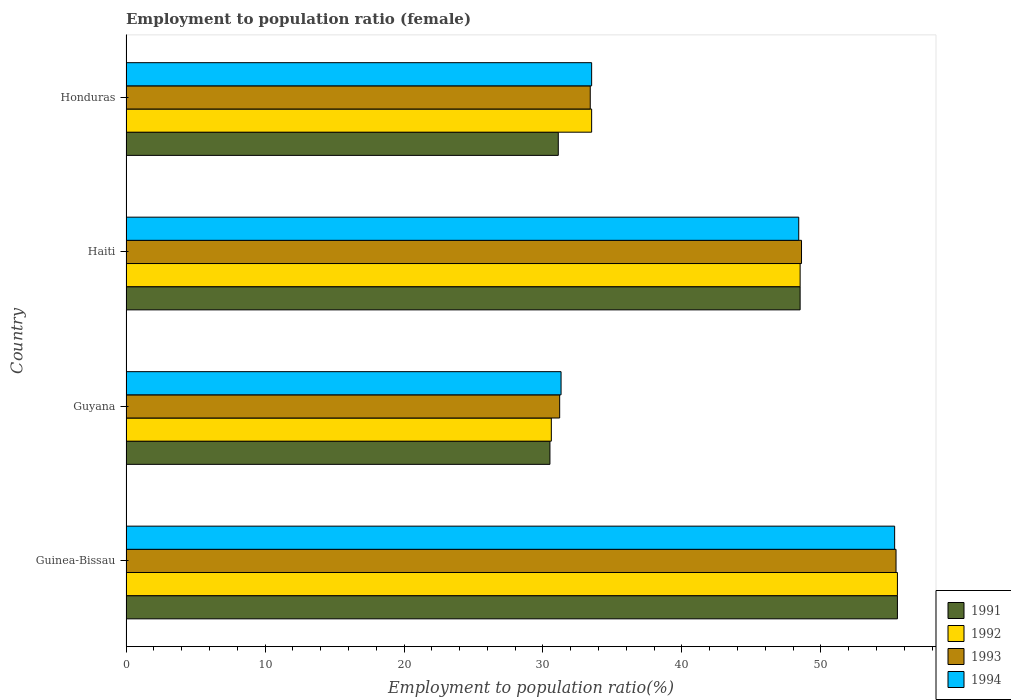How many different coloured bars are there?
Offer a very short reply. 4. How many groups of bars are there?
Your answer should be very brief. 4. Are the number of bars on each tick of the Y-axis equal?
Keep it short and to the point. Yes. What is the label of the 4th group of bars from the top?
Provide a succinct answer. Guinea-Bissau. In how many cases, is the number of bars for a given country not equal to the number of legend labels?
Your response must be concise. 0. What is the employment to population ratio in 1994 in Guyana?
Your answer should be very brief. 31.3. Across all countries, what is the maximum employment to population ratio in 1994?
Offer a very short reply. 55.3. Across all countries, what is the minimum employment to population ratio in 1993?
Keep it short and to the point. 31.2. In which country was the employment to population ratio in 1994 maximum?
Keep it short and to the point. Guinea-Bissau. In which country was the employment to population ratio in 1991 minimum?
Give a very brief answer. Guyana. What is the total employment to population ratio in 1993 in the graph?
Provide a short and direct response. 168.6. What is the difference between the employment to population ratio in 1991 in Guinea-Bissau and that in Honduras?
Your answer should be compact. 24.4. What is the difference between the employment to population ratio in 1993 in Guinea-Bissau and the employment to population ratio in 1992 in Haiti?
Your answer should be compact. 6.9. What is the average employment to population ratio in 1992 per country?
Give a very brief answer. 42.03. What is the difference between the employment to population ratio in 1991 and employment to population ratio in 1993 in Haiti?
Offer a very short reply. -0.1. In how many countries, is the employment to population ratio in 1992 greater than 6 %?
Keep it short and to the point. 4. What is the ratio of the employment to population ratio in 1992 in Guyana to that in Honduras?
Ensure brevity in your answer.  0.91. Is the difference between the employment to population ratio in 1991 in Guinea-Bissau and Guyana greater than the difference between the employment to population ratio in 1993 in Guinea-Bissau and Guyana?
Your response must be concise. Yes. What is the difference between the highest and the second highest employment to population ratio in 1994?
Provide a short and direct response. 6.9. What is the difference between the highest and the lowest employment to population ratio in 1991?
Provide a succinct answer. 25. In how many countries, is the employment to population ratio in 1991 greater than the average employment to population ratio in 1991 taken over all countries?
Ensure brevity in your answer.  2. Is the sum of the employment to population ratio in 1993 in Guinea-Bissau and Honduras greater than the maximum employment to population ratio in 1991 across all countries?
Keep it short and to the point. Yes. Is it the case that in every country, the sum of the employment to population ratio in 1994 and employment to population ratio in 1993 is greater than the sum of employment to population ratio in 1992 and employment to population ratio in 1991?
Your response must be concise. No. What does the 1st bar from the top in Haiti represents?
Ensure brevity in your answer.  1994. Is it the case that in every country, the sum of the employment to population ratio in 1993 and employment to population ratio in 1994 is greater than the employment to population ratio in 1992?
Your answer should be very brief. Yes. How many bars are there?
Offer a very short reply. 16. Are all the bars in the graph horizontal?
Offer a terse response. Yes. How many countries are there in the graph?
Ensure brevity in your answer.  4. What is the difference between two consecutive major ticks on the X-axis?
Provide a short and direct response. 10. Are the values on the major ticks of X-axis written in scientific E-notation?
Your answer should be very brief. No. What is the title of the graph?
Keep it short and to the point. Employment to population ratio (female). Does "2013" appear as one of the legend labels in the graph?
Your response must be concise. No. What is the label or title of the X-axis?
Offer a very short reply. Employment to population ratio(%). What is the label or title of the Y-axis?
Offer a very short reply. Country. What is the Employment to population ratio(%) in 1991 in Guinea-Bissau?
Ensure brevity in your answer.  55.5. What is the Employment to population ratio(%) in 1992 in Guinea-Bissau?
Offer a terse response. 55.5. What is the Employment to population ratio(%) of 1993 in Guinea-Bissau?
Your answer should be compact. 55.4. What is the Employment to population ratio(%) in 1994 in Guinea-Bissau?
Provide a succinct answer. 55.3. What is the Employment to population ratio(%) of 1991 in Guyana?
Keep it short and to the point. 30.5. What is the Employment to population ratio(%) in 1992 in Guyana?
Provide a succinct answer. 30.6. What is the Employment to population ratio(%) in 1993 in Guyana?
Keep it short and to the point. 31.2. What is the Employment to population ratio(%) of 1994 in Guyana?
Provide a short and direct response. 31.3. What is the Employment to population ratio(%) in 1991 in Haiti?
Offer a terse response. 48.5. What is the Employment to population ratio(%) in 1992 in Haiti?
Ensure brevity in your answer.  48.5. What is the Employment to population ratio(%) in 1993 in Haiti?
Offer a terse response. 48.6. What is the Employment to population ratio(%) of 1994 in Haiti?
Your answer should be compact. 48.4. What is the Employment to population ratio(%) of 1991 in Honduras?
Ensure brevity in your answer.  31.1. What is the Employment to population ratio(%) in 1992 in Honduras?
Provide a short and direct response. 33.5. What is the Employment to population ratio(%) of 1993 in Honduras?
Your answer should be very brief. 33.4. What is the Employment to population ratio(%) of 1994 in Honduras?
Keep it short and to the point. 33.5. Across all countries, what is the maximum Employment to population ratio(%) of 1991?
Keep it short and to the point. 55.5. Across all countries, what is the maximum Employment to population ratio(%) of 1992?
Keep it short and to the point. 55.5. Across all countries, what is the maximum Employment to population ratio(%) of 1993?
Your answer should be very brief. 55.4. Across all countries, what is the maximum Employment to population ratio(%) in 1994?
Make the answer very short. 55.3. Across all countries, what is the minimum Employment to population ratio(%) of 1991?
Offer a terse response. 30.5. Across all countries, what is the minimum Employment to population ratio(%) of 1992?
Your response must be concise. 30.6. Across all countries, what is the minimum Employment to population ratio(%) of 1993?
Your answer should be compact. 31.2. Across all countries, what is the minimum Employment to population ratio(%) of 1994?
Your answer should be compact. 31.3. What is the total Employment to population ratio(%) of 1991 in the graph?
Ensure brevity in your answer.  165.6. What is the total Employment to population ratio(%) in 1992 in the graph?
Make the answer very short. 168.1. What is the total Employment to population ratio(%) in 1993 in the graph?
Make the answer very short. 168.6. What is the total Employment to population ratio(%) of 1994 in the graph?
Your answer should be compact. 168.5. What is the difference between the Employment to population ratio(%) of 1991 in Guinea-Bissau and that in Guyana?
Offer a terse response. 25. What is the difference between the Employment to population ratio(%) of 1992 in Guinea-Bissau and that in Guyana?
Offer a very short reply. 24.9. What is the difference between the Employment to population ratio(%) of 1993 in Guinea-Bissau and that in Guyana?
Ensure brevity in your answer.  24.2. What is the difference between the Employment to population ratio(%) of 1994 in Guinea-Bissau and that in Guyana?
Make the answer very short. 24. What is the difference between the Employment to population ratio(%) in 1992 in Guinea-Bissau and that in Haiti?
Offer a very short reply. 7. What is the difference between the Employment to population ratio(%) of 1993 in Guinea-Bissau and that in Haiti?
Give a very brief answer. 6.8. What is the difference between the Employment to population ratio(%) of 1991 in Guinea-Bissau and that in Honduras?
Your answer should be very brief. 24.4. What is the difference between the Employment to population ratio(%) of 1994 in Guinea-Bissau and that in Honduras?
Give a very brief answer. 21.8. What is the difference between the Employment to population ratio(%) in 1992 in Guyana and that in Haiti?
Your answer should be very brief. -17.9. What is the difference between the Employment to population ratio(%) in 1993 in Guyana and that in Haiti?
Give a very brief answer. -17.4. What is the difference between the Employment to population ratio(%) of 1994 in Guyana and that in Haiti?
Ensure brevity in your answer.  -17.1. What is the difference between the Employment to population ratio(%) of 1991 in Guyana and that in Honduras?
Provide a succinct answer. -0.6. What is the difference between the Employment to population ratio(%) of 1992 in Guyana and that in Honduras?
Give a very brief answer. -2.9. What is the difference between the Employment to population ratio(%) in 1993 in Guyana and that in Honduras?
Your answer should be very brief. -2.2. What is the difference between the Employment to population ratio(%) in 1994 in Guyana and that in Honduras?
Make the answer very short. -2.2. What is the difference between the Employment to population ratio(%) of 1991 in Haiti and that in Honduras?
Provide a succinct answer. 17.4. What is the difference between the Employment to population ratio(%) in 1992 in Haiti and that in Honduras?
Provide a succinct answer. 15. What is the difference between the Employment to population ratio(%) in 1993 in Haiti and that in Honduras?
Make the answer very short. 15.2. What is the difference between the Employment to population ratio(%) of 1994 in Haiti and that in Honduras?
Offer a very short reply. 14.9. What is the difference between the Employment to population ratio(%) in 1991 in Guinea-Bissau and the Employment to population ratio(%) in 1992 in Guyana?
Make the answer very short. 24.9. What is the difference between the Employment to population ratio(%) of 1991 in Guinea-Bissau and the Employment to population ratio(%) of 1993 in Guyana?
Provide a short and direct response. 24.3. What is the difference between the Employment to population ratio(%) of 1991 in Guinea-Bissau and the Employment to population ratio(%) of 1994 in Guyana?
Your response must be concise. 24.2. What is the difference between the Employment to population ratio(%) of 1992 in Guinea-Bissau and the Employment to population ratio(%) of 1993 in Guyana?
Your answer should be very brief. 24.3. What is the difference between the Employment to population ratio(%) in 1992 in Guinea-Bissau and the Employment to population ratio(%) in 1994 in Guyana?
Offer a terse response. 24.2. What is the difference between the Employment to population ratio(%) in 1993 in Guinea-Bissau and the Employment to population ratio(%) in 1994 in Guyana?
Provide a succinct answer. 24.1. What is the difference between the Employment to population ratio(%) of 1992 in Guinea-Bissau and the Employment to population ratio(%) of 1993 in Haiti?
Provide a succinct answer. 6.9. What is the difference between the Employment to population ratio(%) of 1991 in Guinea-Bissau and the Employment to population ratio(%) of 1993 in Honduras?
Offer a terse response. 22.1. What is the difference between the Employment to population ratio(%) in 1992 in Guinea-Bissau and the Employment to population ratio(%) in 1993 in Honduras?
Offer a very short reply. 22.1. What is the difference between the Employment to population ratio(%) of 1992 in Guinea-Bissau and the Employment to population ratio(%) of 1994 in Honduras?
Provide a short and direct response. 22. What is the difference between the Employment to population ratio(%) in 1993 in Guinea-Bissau and the Employment to population ratio(%) in 1994 in Honduras?
Give a very brief answer. 21.9. What is the difference between the Employment to population ratio(%) of 1991 in Guyana and the Employment to population ratio(%) of 1993 in Haiti?
Provide a succinct answer. -18.1. What is the difference between the Employment to population ratio(%) of 1991 in Guyana and the Employment to population ratio(%) of 1994 in Haiti?
Make the answer very short. -17.9. What is the difference between the Employment to population ratio(%) of 1992 in Guyana and the Employment to population ratio(%) of 1994 in Haiti?
Make the answer very short. -17.8. What is the difference between the Employment to population ratio(%) of 1993 in Guyana and the Employment to population ratio(%) of 1994 in Haiti?
Provide a succinct answer. -17.2. What is the difference between the Employment to population ratio(%) of 1991 in Guyana and the Employment to population ratio(%) of 1992 in Honduras?
Your answer should be compact. -3. What is the difference between the Employment to population ratio(%) of 1991 in Guyana and the Employment to population ratio(%) of 1994 in Honduras?
Offer a terse response. -3. What is the difference between the Employment to population ratio(%) of 1993 in Guyana and the Employment to population ratio(%) of 1994 in Honduras?
Offer a terse response. -2.3. What is the difference between the Employment to population ratio(%) of 1991 in Haiti and the Employment to population ratio(%) of 1992 in Honduras?
Keep it short and to the point. 15. What is the difference between the Employment to population ratio(%) of 1991 in Haiti and the Employment to population ratio(%) of 1993 in Honduras?
Offer a terse response. 15.1. What is the difference between the Employment to population ratio(%) of 1992 in Haiti and the Employment to population ratio(%) of 1993 in Honduras?
Your response must be concise. 15.1. What is the average Employment to population ratio(%) of 1991 per country?
Make the answer very short. 41.4. What is the average Employment to population ratio(%) in 1992 per country?
Your answer should be very brief. 42.02. What is the average Employment to population ratio(%) in 1993 per country?
Offer a very short reply. 42.15. What is the average Employment to population ratio(%) in 1994 per country?
Your answer should be very brief. 42.12. What is the difference between the Employment to population ratio(%) in 1991 and Employment to population ratio(%) in 1993 in Guinea-Bissau?
Your answer should be compact. 0.1. What is the difference between the Employment to population ratio(%) of 1991 and Employment to population ratio(%) of 1994 in Guinea-Bissau?
Your answer should be compact. 0.2. What is the difference between the Employment to population ratio(%) of 1993 and Employment to population ratio(%) of 1994 in Guinea-Bissau?
Your answer should be compact. 0.1. What is the difference between the Employment to population ratio(%) in 1991 and Employment to population ratio(%) in 1992 in Guyana?
Offer a very short reply. -0.1. What is the difference between the Employment to population ratio(%) of 1991 and Employment to population ratio(%) of 1993 in Guyana?
Offer a terse response. -0.7. What is the difference between the Employment to population ratio(%) in 1991 and Employment to population ratio(%) in 1994 in Guyana?
Keep it short and to the point. -0.8. What is the difference between the Employment to population ratio(%) in 1993 and Employment to population ratio(%) in 1994 in Guyana?
Give a very brief answer. -0.1. What is the difference between the Employment to population ratio(%) of 1991 and Employment to population ratio(%) of 1992 in Haiti?
Offer a very short reply. 0. What is the difference between the Employment to population ratio(%) in 1991 and Employment to population ratio(%) in 1993 in Haiti?
Your response must be concise. -0.1. What is the difference between the Employment to population ratio(%) in 1991 and Employment to population ratio(%) in 1992 in Honduras?
Your response must be concise. -2.4. What is the difference between the Employment to population ratio(%) of 1991 and Employment to population ratio(%) of 1994 in Honduras?
Your answer should be compact. -2.4. What is the difference between the Employment to population ratio(%) of 1992 and Employment to population ratio(%) of 1993 in Honduras?
Provide a short and direct response. 0.1. What is the ratio of the Employment to population ratio(%) of 1991 in Guinea-Bissau to that in Guyana?
Provide a short and direct response. 1.82. What is the ratio of the Employment to population ratio(%) in 1992 in Guinea-Bissau to that in Guyana?
Your response must be concise. 1.81. What is the ratio of the Employment to population ratio(%) in 1993 in Guinea-Bissau to that in Guyana?
Make the answer very short. 1.78. What is the ratio of the Employment to population ratio(%) in 1994 in Guinea-Bissau to that in Guyana?
Your response must be concise. 1.77. What is the ratio of the Employment to population ratio(%) of 1991 in Guinea-Bissau to that in Haiti?
Your response must be concise. 1.14. What is the ratio of the Employment to population ratio(%) in 1992 in Guinea-Bissau to that in Haiti?
Provide a succinct answer. 1.14. What is the ratio of the Employment to population ratio(%) of 1993 in Guinea-Bissau to that in Haiti?
Your response must be concise. 1.14. What is the ratio of the Employment to population ratio(%) in 1994 in Guinea-Bissau to that in Haiti?
Make the answer very short. 1.14. What is the ratio of the Employment to population ratio(%) of 1991 in Guinea-Bissau to that in Honduras?
Offer a very short reply. 1.78. What is the ratio of the Employment to population ratio(%) of 1992 in Guinea-Bissau to that in Honduras?
Offer a very short reply. 1.66. What is the ratio of the Employment to population ratio(%) in 1993 in Guinea-Bissau to that in Honduras?
Your answer should be very brief. 1.66. What is the ratio of the Employment to population ratio(%) of 1994 in Guinea-Bissau to that in Honduras?
Ensure brevity in your answer.  1.65. What is the ratio of the Employment to population ratio(%) of 1991 in Guyana to that in Haiti?
Your response must be concise. 0.63. What is the ratio of the Employment to population ratio(%) in 1992 in Guyana to that in Haiti?
Ensure brevity in your answer.  0.63. What is the ratio of the Employment to population ratio(%) in 1993 in Guyana to that in Haiti?
Provide a short and direct response. 0.64. What is the ratio of the Employment to population ratio(%) in 1994 in Guyana to that in Haiti?
Give a very brief answer. 0.65. What is the ratio of the Employment to population ratio(%) of 1991 in Guyana to that in Honduras?
Your answer should be very brief. 0.98. What is the ratio of the Employment to population ratio(%) in 1992 in Guyana to that in Honduras?
Offer a very short reply. 0.91. What is the ratio of the Employment to population ratio(%) in 1993 in Guyana to that in Honduras?
Provide a succinct answer. 0.93. What is the ratio of the Employment to population ratio(%) of 1994 in Guyana to that in Honduras?
Your answer should be compact. 0.93. What is the ratio of the Employment to population ratio(%) in 1991 in Haiti to that in Honduras?
Ensure brevity in your answer.  1.56. What is the ratio of the Employment to population ratio(%) in 1992 in Haiti to that in Honduras?
Provide a succinct answer. 1.45. What is the ratio of the Employment to population ratio(%) in 1993 in Haiti to that in Honduras?
Provide a short and direct response. 1.46. What is the ratio of the Employment to population ratio(%) in 1994 in Haiti to that in Honduras?
Your answer should be very brief. 1.44. What is the difference between the highest and the lowest Employment to population ratio(%) in 1991?
Provide a succinct answer. 25. What is the difference between the highest and the lowest Employment to population ratio(%) in 1992?
Offer a very short reply. 24.9. What is the difference between the highest and the lowest Employment to population ratio(%) of 1993?
Your response must be concise. 24.2. What is the difference between the highest and the lowest Employment to population ratio(%) of 1994?
Give a very brief answer. 24. 